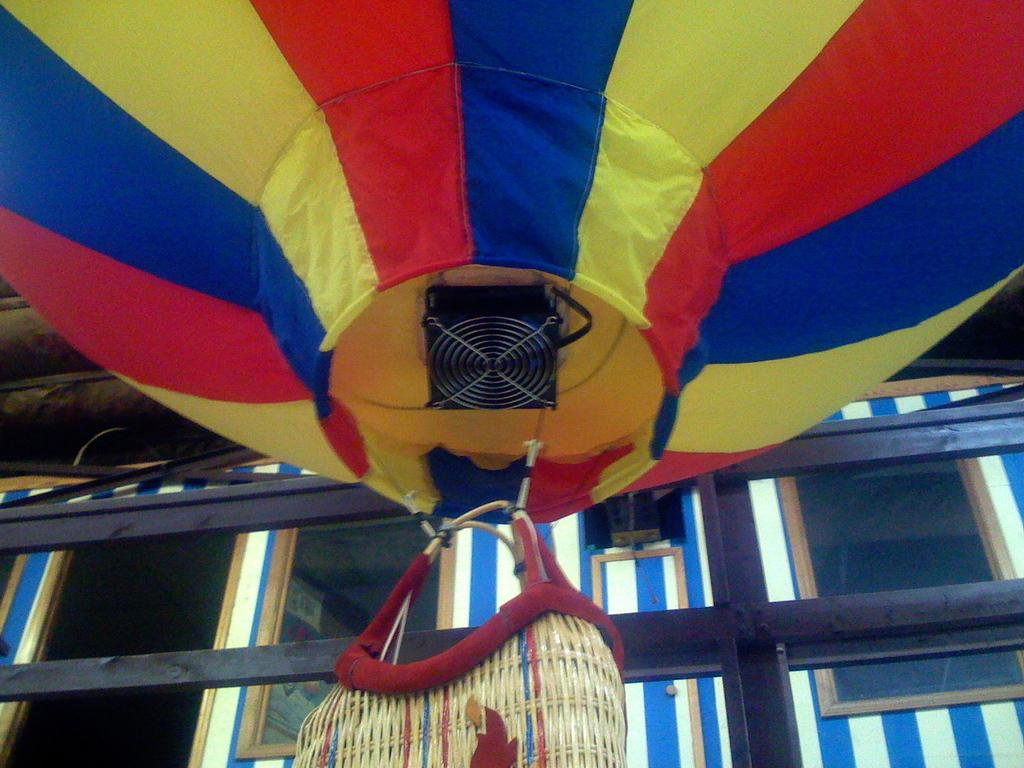What is the main object featured in the image? There is a parachute in the image. What other item can be seen in the image? There is a bag in the image. What can be seen in the background of the image? There are glasses and a wall in the background of the image. What type of boat can be seen in the image? There is no boat present in the image. How does the belief system of the person in the image affect their decision to use the parachute? There is no information about the person's belief system or their decision-making process in the image. 